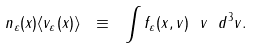<formula> <loc_0><loc_0><loc_500><loc_500>n _ { \varepsilon } ( x ) \langle { v } _ { \varepsilon } ( x ) \rangle \ \equiv \ \int f _ { \varepsilon } ( x , v ) \ { v } \ d ^ { 3 } v .</formula> 